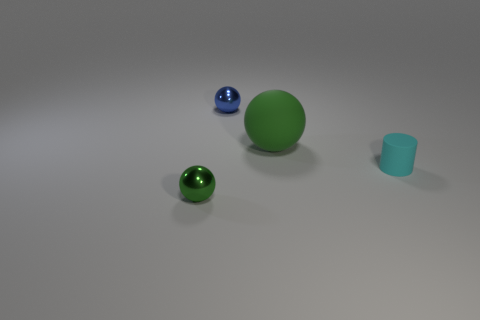Subtract all tiny blue metallic spheres. How many spheres are left? 2 Add 3 purple cylinders. How many objects exist? 7 Subtract all green cubes. How many green spheres are left? 2 Subtract all spheres. How many objects are left? 1 Subtract all small gray balls. Subtract all shiny balls. How many objects are left? 2 Add 3 large green objects. How many large green objects are left? 4 Add 1 big brown metal blocks. How many big brown metal blocks exist? 1 Subtract 1 blue spheres. How many objects are left? 3 Subtract all red cylinders. Subtract all yellow cubes. How many cylinders are left? 1 